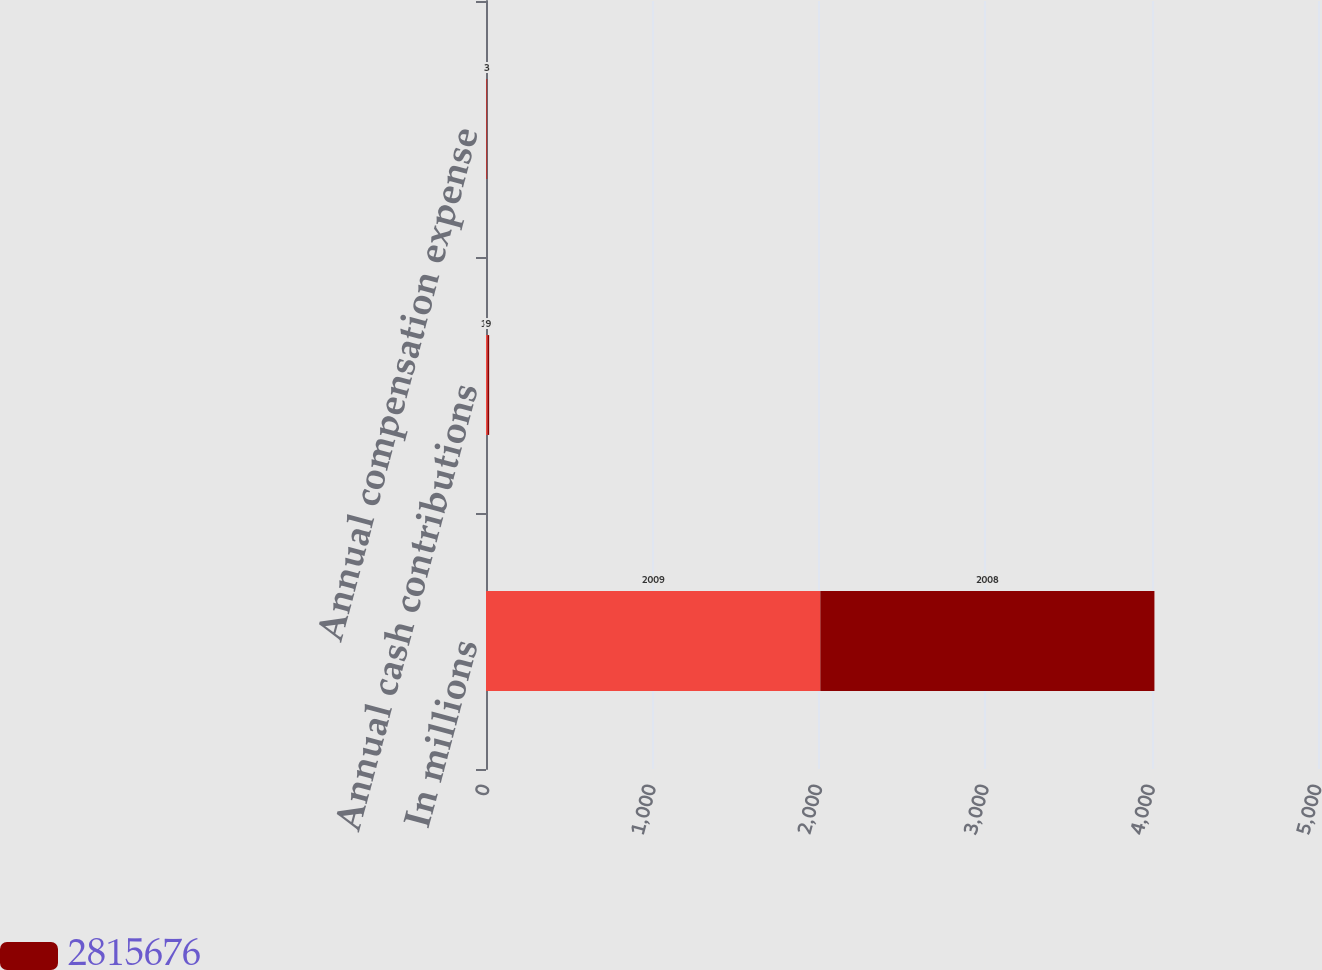Convert chart to OTSL. <chart><loc_0><loc_0><loc_500><loc_500><stacked_bar_chart><ecel><fcel>In millions<fcel>Annual cash contributions<fcel>Annual compensation expense<nl><fcel>nan<fcel>2009<fcel>10<fcel>4<nl><fcel>2.81568e+06<fcel>2008<fcel>9<fcel>3<nl></chart> 